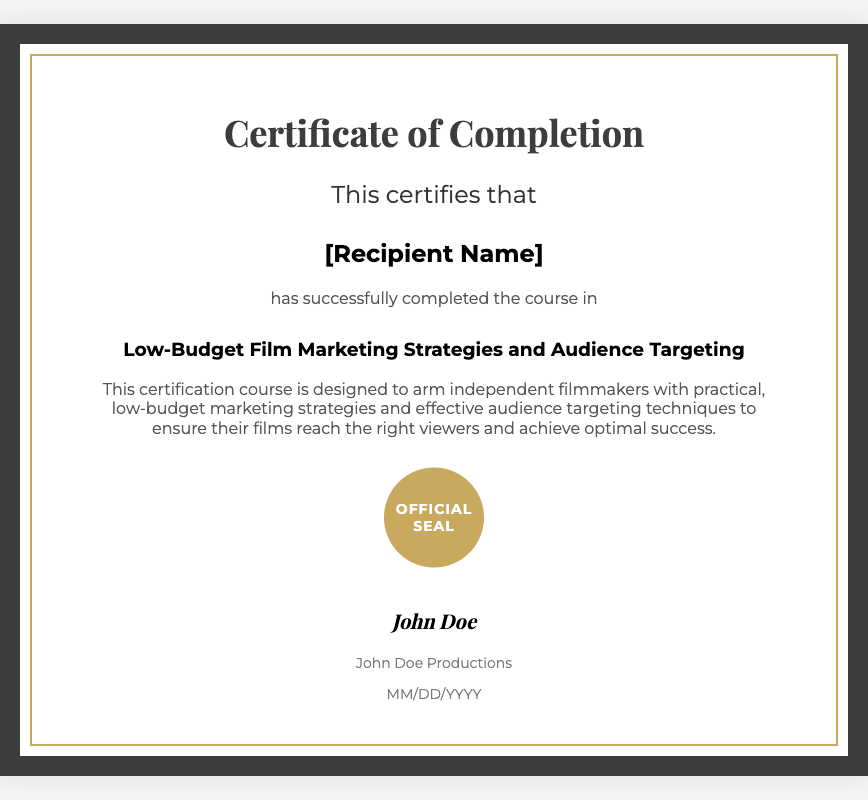What is the title of the course? The title of the course is explicitly stated in the document as "Low-Budget Film Marketing Strategies and Audience Targeting."
Answer: Low-Budget Film Marketing Strategies and Audience Targeting Who is the recipient of the certificate? The recipient's name is indicated in the document at the position [Recipient Name], which is a placeholder for the actual name.
Answer: [Recipient Name] What does this certification course aim to provide? The document describes that the course is designed to arm independent filmmakers with practical marketing strategies and effective audience targeting techniques.
Answer: Practical marketing strategies and effective audience targeting techniques Who issued the certificate? The issuer of the certificate is mentioned as "John Doe Productions" at the bottom of the document.
Answer: John Doe Productions What is the date format shown in the certificate? The date format specified in the document is indicated as "MM/DD/YYYY," which is a common way to format dates.
Answer: MM/DD/YYYY What is the significance of the seal mentioned in the document? The seal labeled "Official Seal" serves as an official mark of the document and certification, signifying its legitimacy.
Answer: Official Seal How does the certificate describe its target audience? The audience is described as independent filmmakers who need low-budget marketing strategies, referenced throughout the description.
Answer: Independent filmmakers What color is the border of the certificate? The border is described to have a color of "#3d3d3d" which is a dark gray, giving the certificate a solid appearance.
Answer: Dark gray 